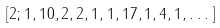Convert formula to latex. <formula><loc_0><loc_0><loc_500><loc_500>[ 2 ; 1 , 1 0 , 2 , 2 , 1 , 1 , 1 7 , 1 , 4 , 1 , \dots ]</formula> 